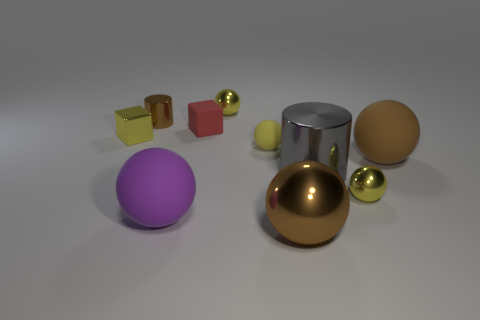Subtract all yellow balls. How many were subtracted if there are1yellow balls left? 2 Subtract all brown cubes. How many brown spheres are left? 2 Subtract all big brown rubber spheres. How many spheres are left? 5 Subtract all brown balls. How many balls are left? 4 Subtract 4 spheres. How many spheres are left? 2 Subtract all cylinders. How many objects are left? 8 Subtract all blue spheres. Subtract all gray cylinders. How many spheres are left? 6 Add 6 purple rubber things. How many purple rubber things exist? 7 Subtract 0 purple cubes. How many objects are left? 10 Subtract all metal things. Subtract all large gray cylinders. How many objects are left? 3 